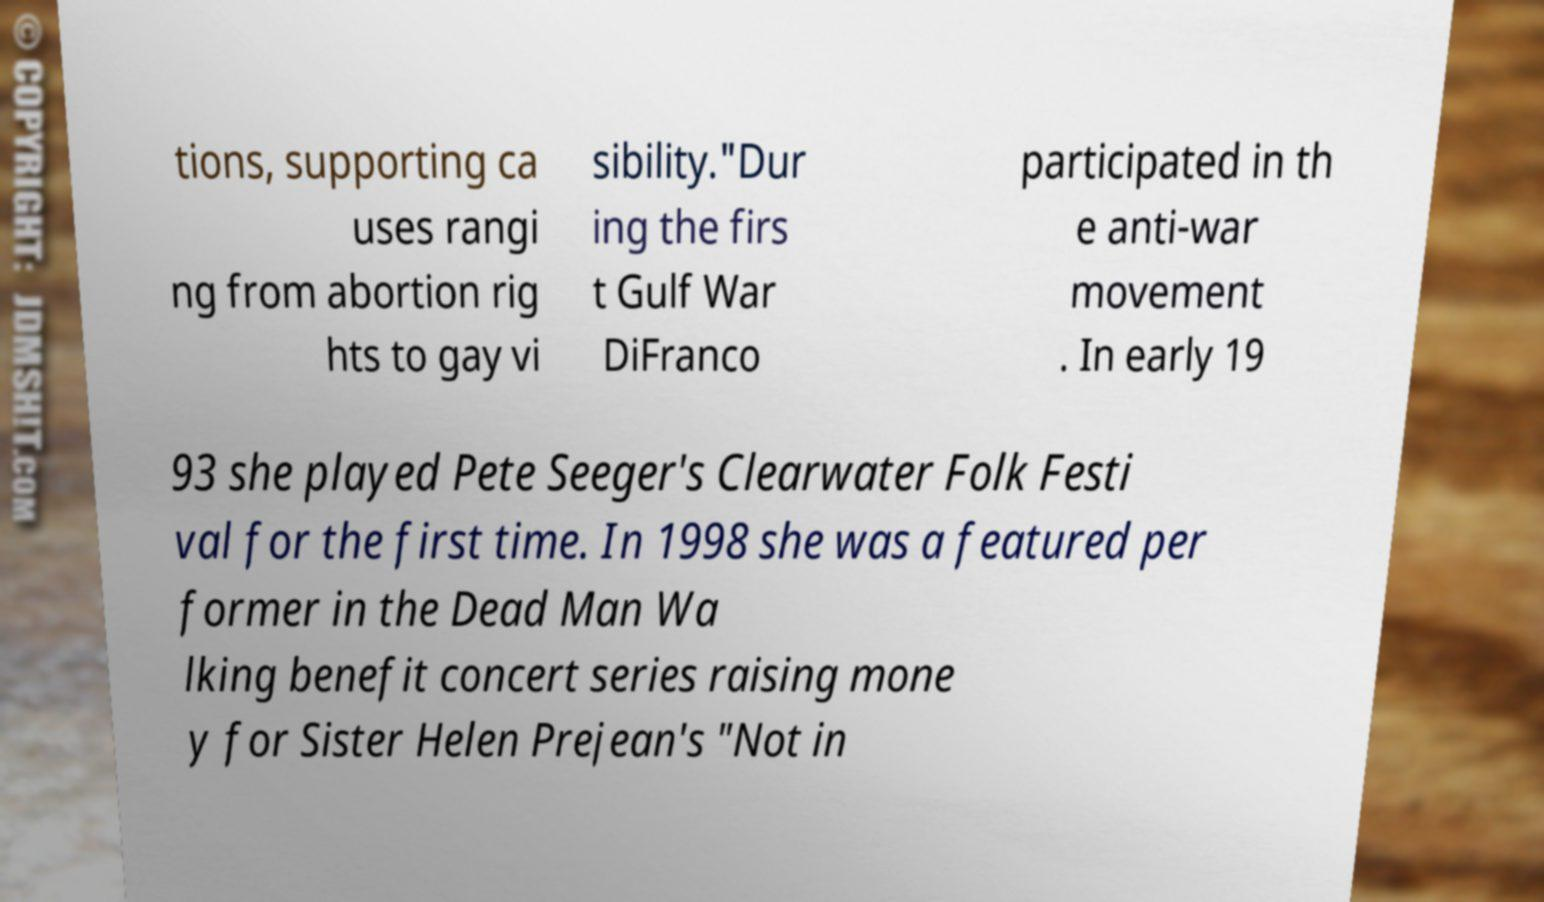Please read and relay the text visible in this image. What does it say? tions, supporting ca uses rangi ng from abortion rig hts to gay vi sibility."Dur ing the firs t Gulf War DiFranco participated in th e anti-war movement . In early 19 93 she played Pete Seeger's Clearwater Folk Festi val for the first time. In 1998 she was a featured per former in the Dead Man Wa lking benefit concert series raising mone y for Sister Helen Prejean's "Not in 